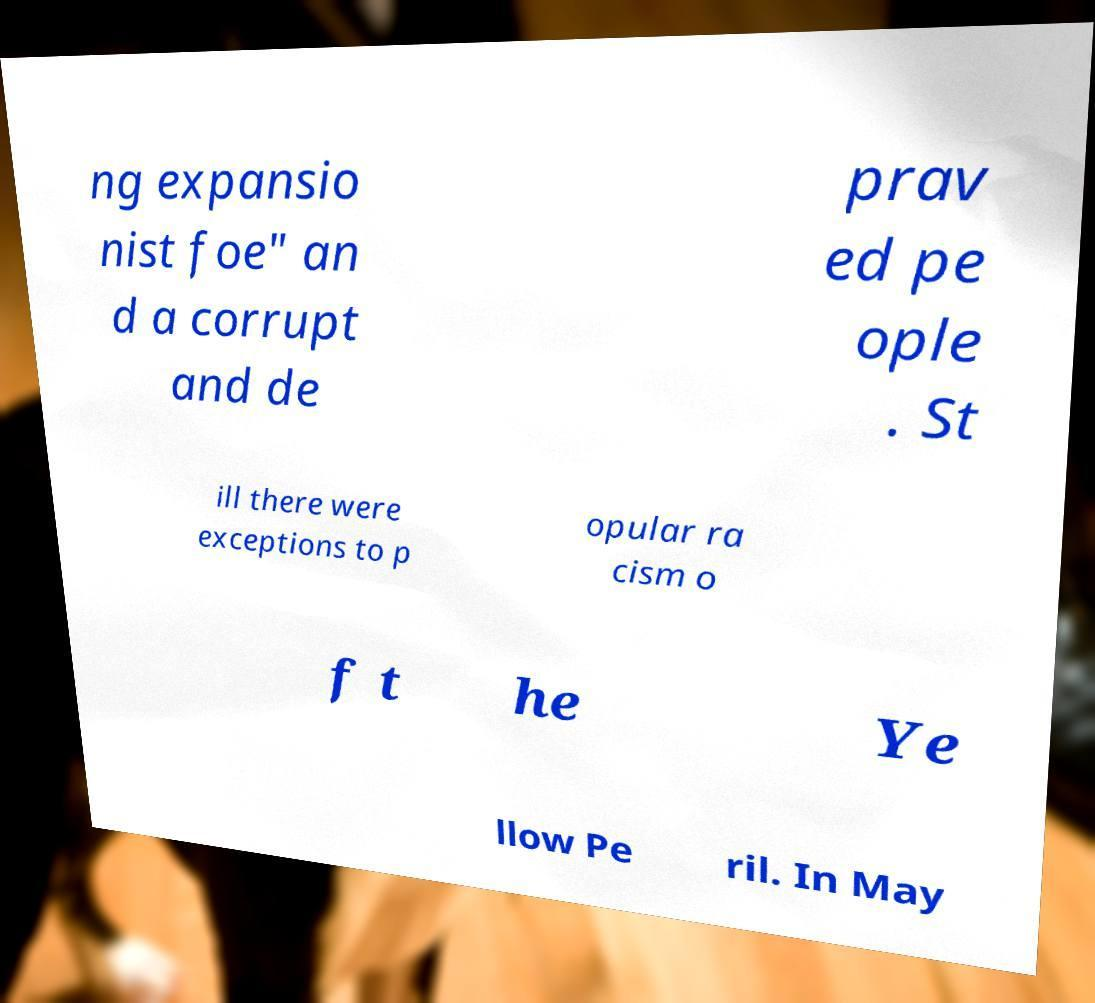Could you assist in decoding the text presented in this image and type it out clearly? ng expansio nist foe" an d a corrupt and de prav ed pe ople . St ill there were exceptions to p opular ra cism o f t he Ye llow Pe ril. In May 